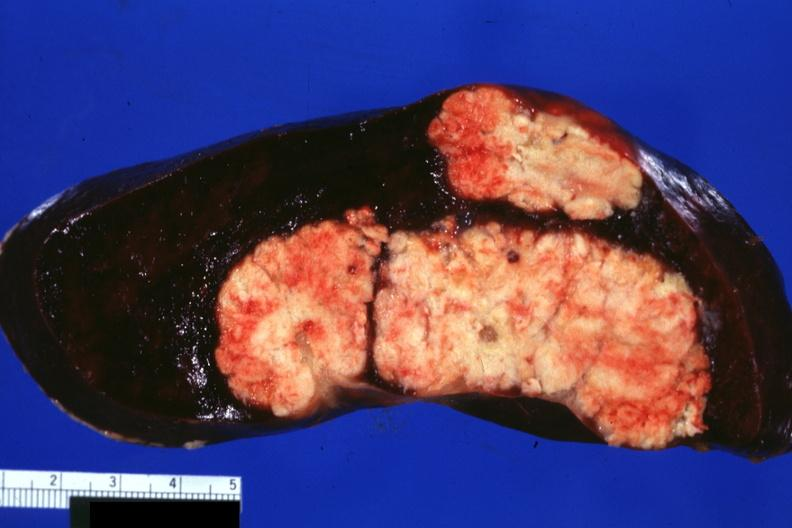does granuloma show large and very typical metastatic lesions in spleen very well shown?
Answer the question using a single word or phrase. No 